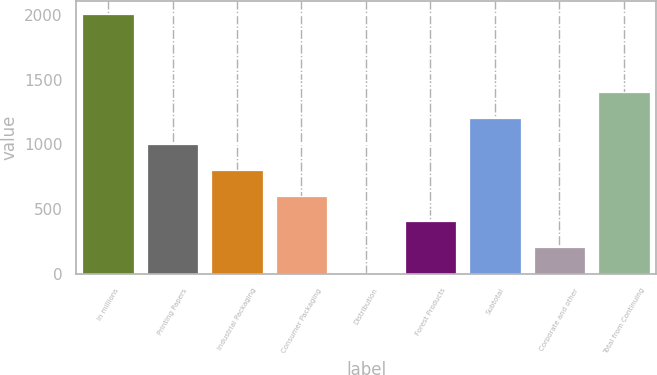<chart> <loc_0><loc_0><loc_500><loc_500><bar_chart><fcel>In millions<fcel>Printing Papers<fcel>Industrial Packaging<fcel>Consumer Packaging<fcel>Distribution<fcel>Forest Products<fcel>Subtotal<fcel>Corporate and other<fcel>Total from Continuing<nl><fcel>2006<fcel>1006<fcel>806<fcel>606<fcel>6<fcel>406<fcel>1206<fcel>206<fcel>1406<nl></chart> 